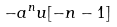<formula> <loc_0><loc_0><loc_500><loc_500>- a ^ { n } u [ - n - 1 ]</formula> 